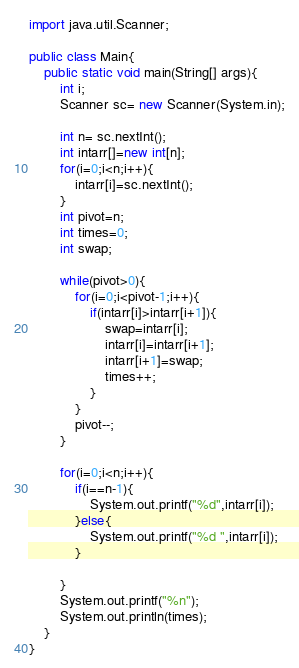<code> <loc_0><loc_0><loc_500><loc_500><_Java_>import java.util.Scanner;

public class Main{
    public static void main(String[] args){
        int i;
        Scanner sc= new Scanner(System.in);

        int n= sc.nextInt();
        int intarr[]=new int[n];
        for(i=0;i<n;i++){
            intarr[i]=sc.nextInt(); 
        }
        int pivot=n;
        int times=0;
        int swap;

        while(pivot>0){
            for(i=0;i<pivot-1;i++){
                if(intarr[i]>intarr[i+1]){
                    swap=intarr[i];
                    intarr[i]=intarr[i+1];
                    intarr[i+1]=swap;
                    times++;
                }                
            }
            pivot--;
        }

        for(i=0;i<n;i++){
            if(i==n-1){
                System.out.printf("%d",intarr[i]);
            }else{
                System.out.printf("%d ",intarr[i]);
            }
            
        }
        System.out.printf("%n");
        System.out.println(times);
    }    
}
</code> 